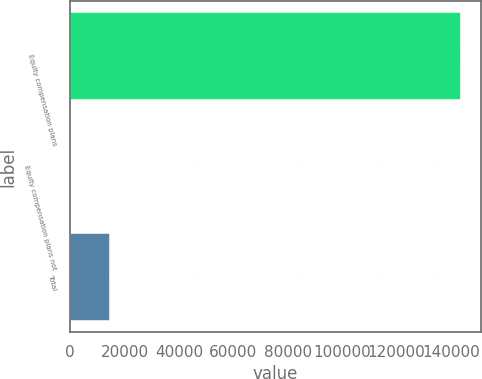Convert chart to OTSL. <chart><loc_0><loc_0><loc_500><loc_500><bar_chart><fcel>Equity compensation plans<fcel>Equity compensation plans not<fcel>Total<nl><fcel>143802<fcel>217<fcel>14597<nl></chart> 